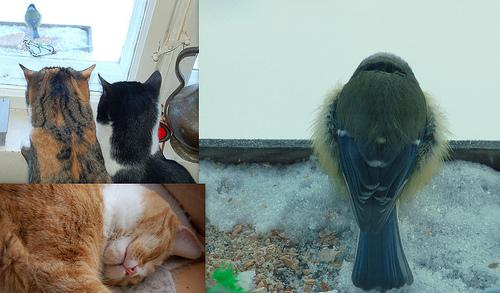Highlight the different animals in the image, their colors, and any interesting features. There's an orange cat, a dark orange cat, another cat with a white patch on its neck, and a fluffy bird with a blue tail. List the objects in the image and provide a brief description for each. Cats watching: Eyes closed, dark orange fur, and cats' ears. Summarize the scenario involving the main subjects in the image. Sleeping and watching cats gather near a window, observing a bird on the ground, surrounded by seeds, rocks, and green furry objects. Mention the primary object in the image and their activity. There is a cat sleeping, and two other cats are looking out the window, watching a bird on the ground. Explain the interaction between the main subjects and their surroundings in the image. Two cats watch a bird from a window, while a sleeping cat with a pink nose rests nearby and green furry objects and seeds lie on the ground. Provide a detailed description of the animals in the image, including any unique traits they may have. There are several cats with distinct fur colors, pink noses, and white patches, and a fluffy bird with a blue tail on the ground. Briefly outline the animal-related events occurring in the image. In the image, cats are either sleeping or watching a bird, while the bird is sitting on the ground with its blue tail showing. Narrate the scene involving the cats and the bird in the image. Two cats are watching a bird while another cat is sleeping with a pink nose, and there's a white patch on a cat's neck. Describe the environment around the main subjects in the image. The cats are near a window and a kettle, the sleeping cat has a white patch on its neck, and there are seeds and rocks on the snow. Identify the different colours of objects and their characteristics in the image. There are dark orange, pink-nosed, and orange cats along with a fluffy blue-tailed bird, a green furry object, and snow on the roof. 